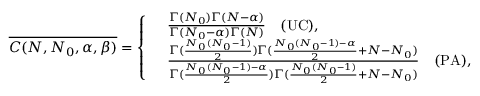Convert formula to latex. <formula><loc_0><loc_0><loc_500><loc_500>\overline { { C ( N , N _ { 0 } , \alpha , \beta ) } } = \left \{ \begin{array} { r l } & { \frac { \Gamma ( N _ { 0 } ) \Gamma ( N - \alpha ) } { \Gamma ( N _ { 0 } - \alpha ) \Gamma ( N ) } \quad ( U C ) , } \\ & { \frac { \Gamma ( \frac { N _ { 0 } ( N _ { 0 } - 1 ) } { 2 } ) \Gamma ( \frac { N _ { 0 } ( N _ { 0 } - 1 ) - \alpha } { 2 } + N - N _ { 0 } ) } { \Gamma ( \frac { N _ { 0 } ( N _ { 0 } - 1 ) - \alpha } { 2 } ) \Gamma ( \frac { N _ { 0 } ( N _ { 0 } - 1 ) } { 2 } + N - N _ { 0 } ) } \quad ( P A ) , } \end{array}</formula> 